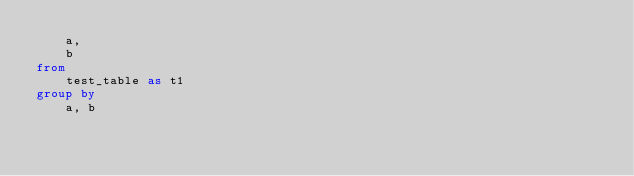Convert code to text. <code><loc_0><loc_0><loc_500><loc_500><_SQL_>    a,
    b
from
    test_table as t1
group by
    a, b
</code> 